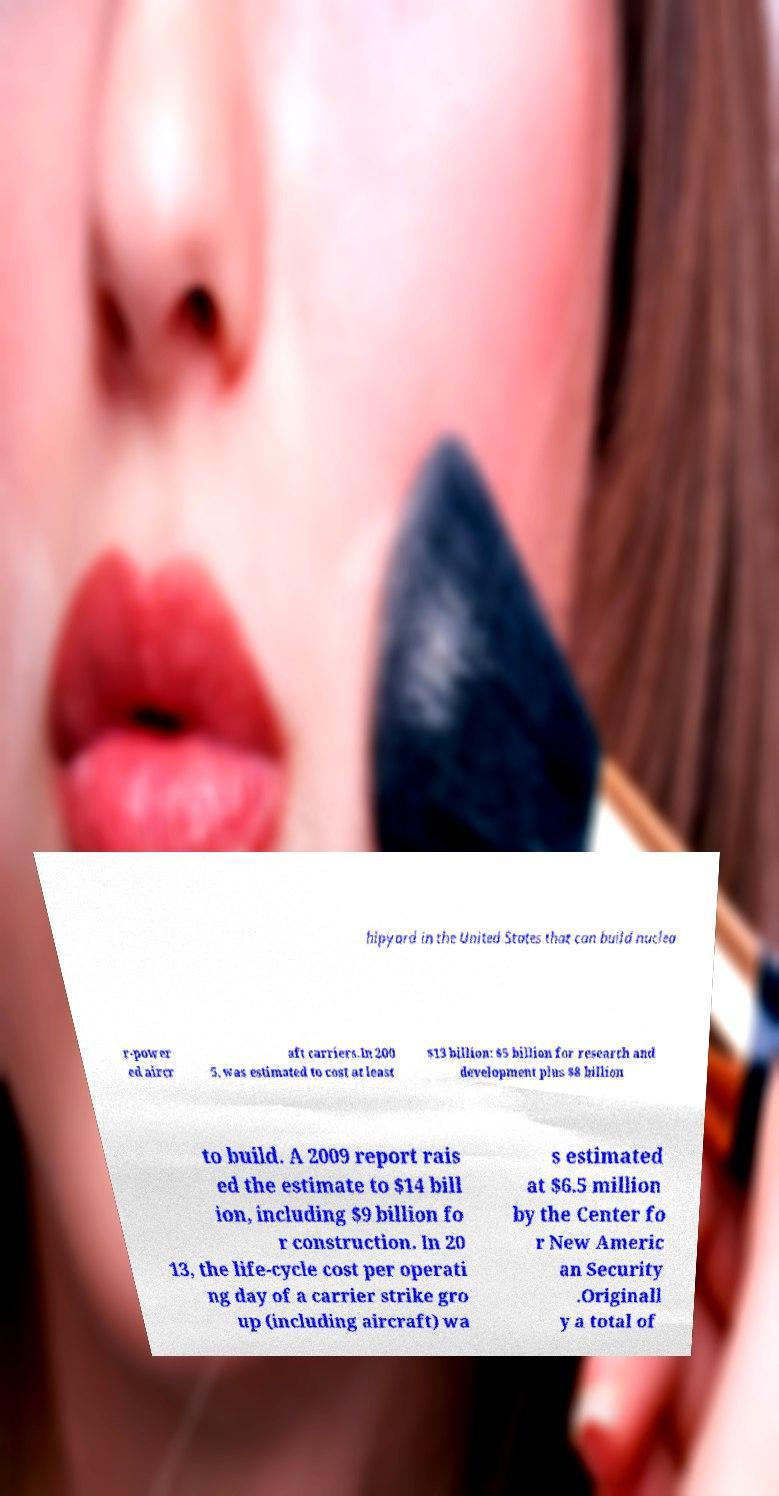I need the written content from this picture converted into text. Can you do that? hipyard in the United States that can build nuclea r-power ed aircr aft carriers.In 200 5, was estimated to cost at least $13 billion: $5 billion for research and development plus $8 billion to build. A 2009 report rais ed the estimate to $14 bill ion, including $9 billion fo r construction. In 20 13, the life-cycle cost per operati ng day of a carrier strike gro up (including aircraft) wa s estimated at $6.5 million by the Center fo r New Americ an Security .Originall y a total of 